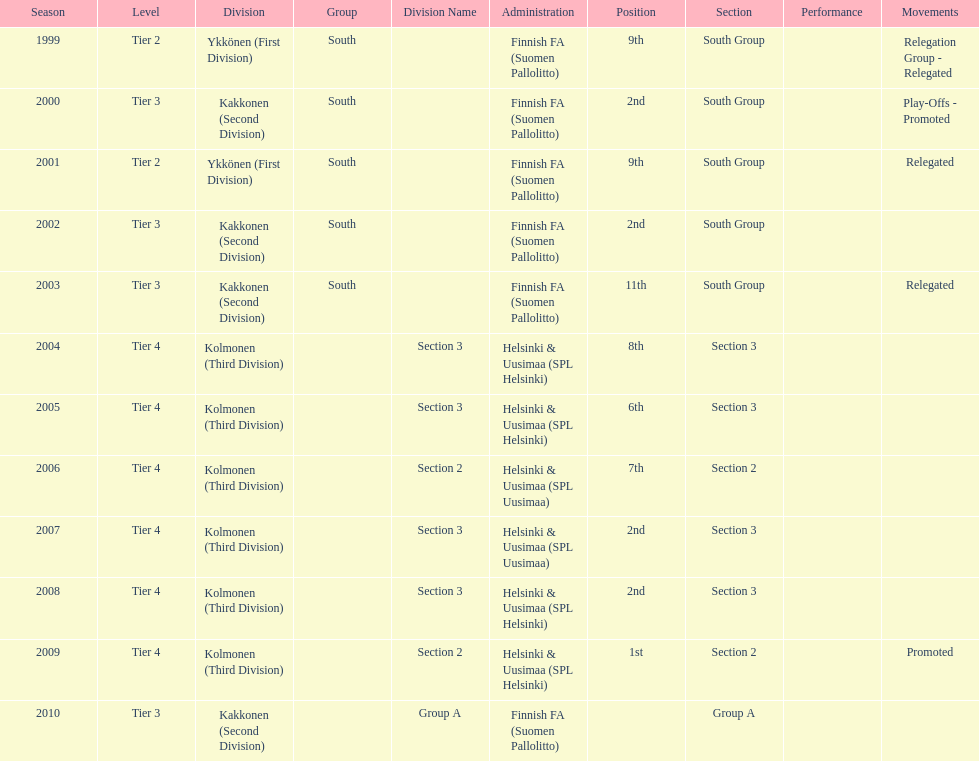What division were they in the most, section 3 or 2? 3. 